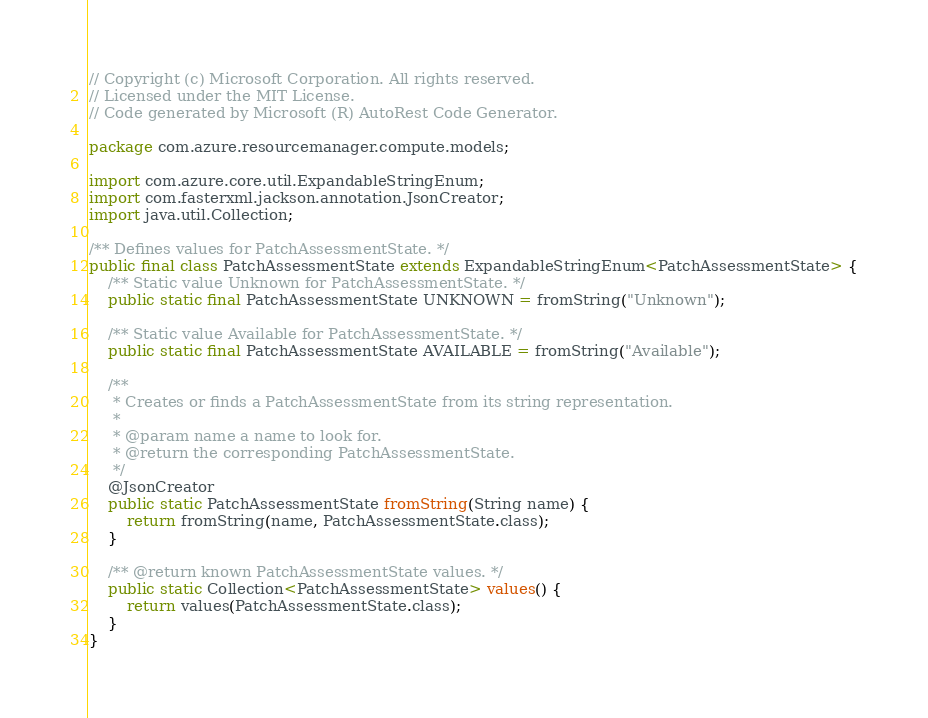<code> <loc_0><loc_0><loc_500><loc_500><_Java_>// Copyright (c) Microsoft Corporation. All rights reserved.
// Licensed under the MIT License.
// Code generated by Microsoft (R) AutoRest Code Generator.

package com.azure.resourcemanager.compute.models;

import com.azure.core.util.ExpandableStringEnum;
import com.fasterxml.jackson.annotation.JsonCreator;
import java.util.Collection;

/** Defines values for PatchAssessmentState. */
public final class PatchAssessmentState extends ExpandableStringEnum<PatchAssessmentState> {
    /** Static value Unknown for PatchAssessmentState. */
    public static final PatchAssessmentState UNKNOWN = fromString("Unknown");

    /** Static value Available for PatchAssessmentState. */
    public static final PatchAssessmentState AVAILABLE = fromString("Available");

    /**
     * Creates or finds a PatchAssessmentState from its string representation.
     *
     * @param name a name to look for.
     * @return the corresponding PatchAssessmentState.
     */
    @JsonCreator
    public static PatchAssessmentState fromString(String name) {
        return fromString(name, PatchAssessmentState.class);
    }

    /** @return known PatchAssessmentState values. */
    public static Collection<PatchAssessmentState> values() {
        return values(PatchAssessmentState.class);
    }
}
</code> 